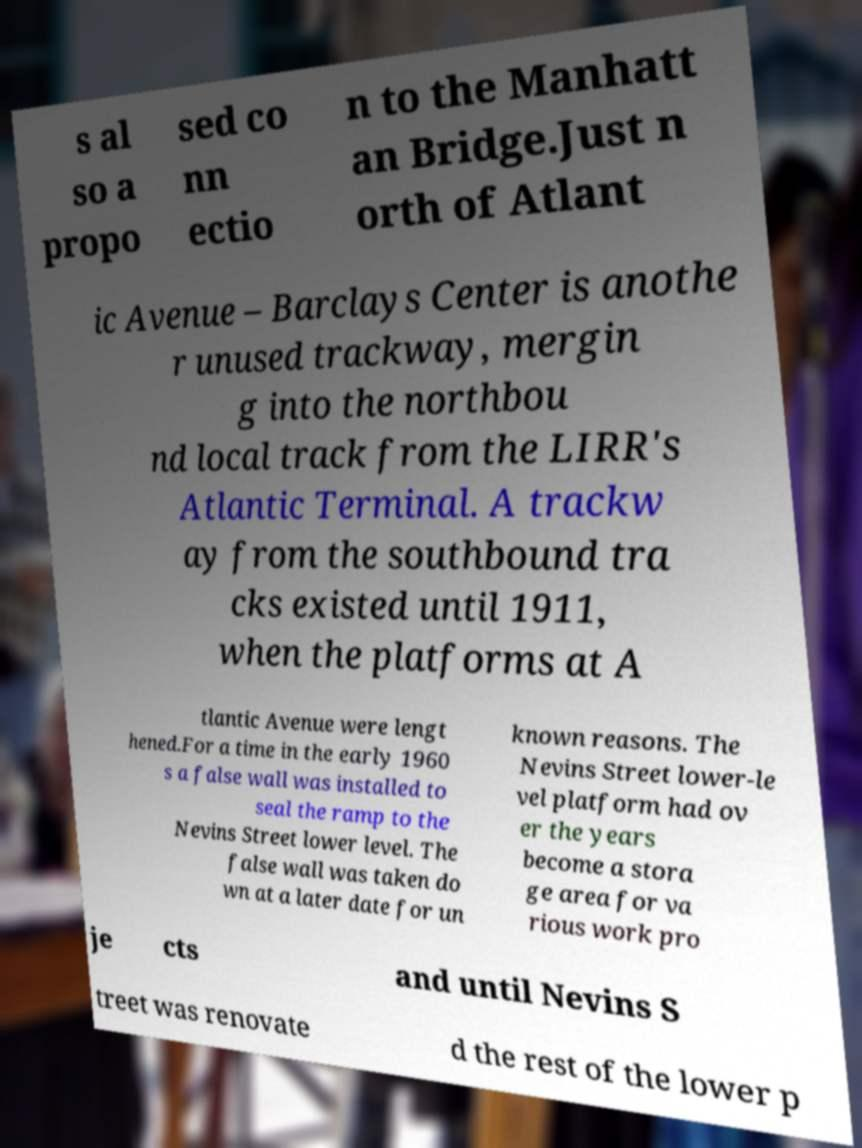Please read and relay the text visible in this image. What does it say? s al so a propo sed co nn ectio n to the Manhatt an Bridge.Just n orth of Atlant ic Avenue – Barclays Center is anothe r unused trackway, mergin g into the northbou nd local track from the LIRR's Atlantic Terminal. A trackw ay from the southbound tra cks existed until 1911, when the platforms at A tlantic Avenue were lengt hened.For a time in the early 1960 s a false wall was installed to seal the ramp to the Nevins Street lower level. The false wall was taken do wn at a later date for un known reasons. The Nevins Street lower-le vel platform had ov er the years become a stora ge area for va rious work pro je cts and until Nevins S treet was renovate d the rest of the lower p 